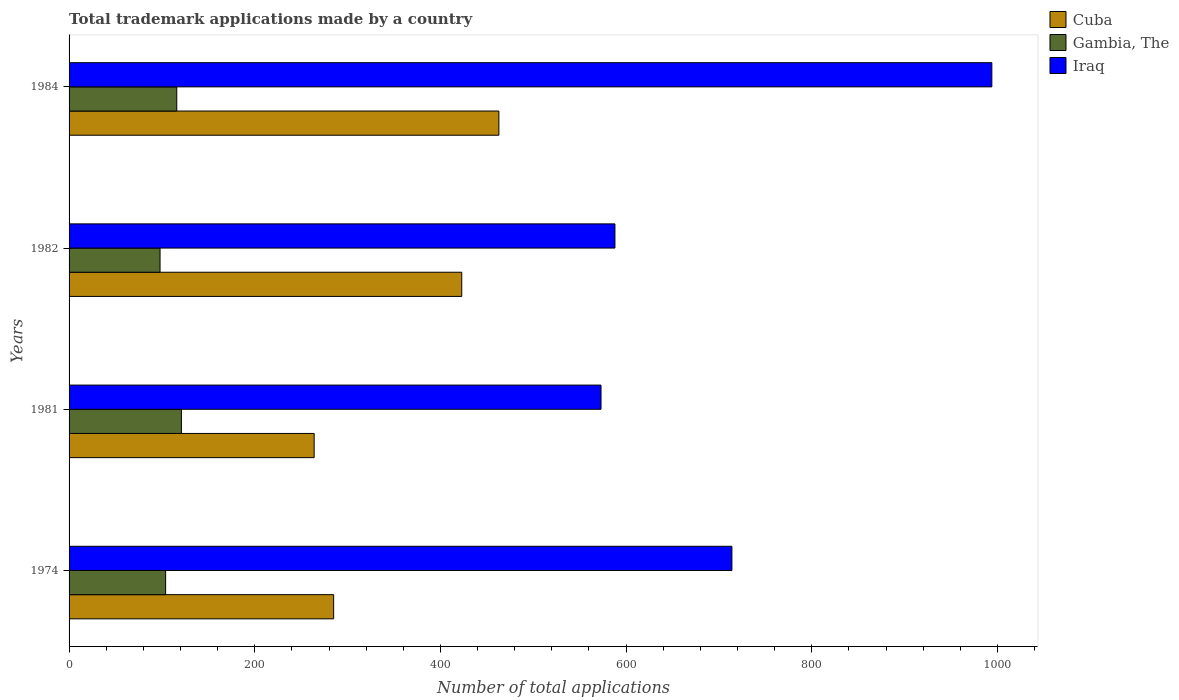How many bars are there on the 3rd tick from the bottom?
Your answer should be compact. 3. What is the label of the 1st group of bars from the top?
Offer a very short reply. 1984. What is the number of applications made by in Gambia, The in 1984?
Offer a very short reply. 116. Across all years, what is the maximum number of applications made by in Cuba?
Your answer should be compact. 463. Across all years, what is the minimum number of applications made by in Cuba?
Your response must be concise. 264. In which year was the number of applications made by in Iraq maximum?
Give a very brief answer. 1984. What is the total number of applications made by in Cuba in the graph?
Keep it short and to the point. 1435. What is the difference between the number of applications made by in Gambia, The in 1981 and that in 1984?
Offer a terse response. 5. What is the difference between the number of applications made by in Cuba in 1981 and the number of applications made by in Gambia, The in 1982?
Keep it short and to the point. 166. What is the average number of applications made by in Gambia, The per year?
Offer a very short reply. 109.75. In the year 1981, what is the difference between the number of applications made by in Gambia, The and number of applications made by in Cuba?
Keep it short and to the point. -143. In how many years, is the number of applications made by in Cuba greater than 120 ?
Ensure brevity in your answer.  4. What is the ratio of the number of applications made by in Cuba in 1982 to that in 1984?
Provide a succinct answer. 0.91. What is the difference between the highest and the lowest number of applications made by in Iraq?
Keep it short and to the point. 421. What does the 3rd bar from the top in 1982 represents?
Offer a very short reply. Cuba. What does the 2nd bar from the bottom in 1974 represents?
Provide a succinct answer. Gambia, The. Is it the case that in every year, the sum of the number of applications made by in Iraq and number of applications made by in Cuba is greater than the number of applications made by in Gambia, The?
Give a very brief answer. Yes. How many bars are there?
Your answer should be very brief. 12. Are all the bars in the graph horizontal?
Give a very brief answer. Yes. Are the values on the major ticks of X-axis written in scientific E-notation?
Your answer should be compact. No. Does the graph contain any zero values?
Give a very brief answer. No. Where does the legend appear in the graph?
Keep it short and to the point. Top right. How many legend labels are there?
Make the answer very short. 3. How are the legend labels stacked?
Provide a succinct answer. Vertical. What is the title of the graph?
Your answer should be very brief. Total trademark applications made by a country. Does "Europe(developing only)" appear as one of the legend labels in the graph?
Provide a short and direct response. No. What is the label or title of the X-axis?
Offer a terse response. Number of total applications. What is the Number of total applications in Cuba in 1974?
Your answer should be very brief. 285. What is the Number of total applications of Gambia, The in 1974?
Your response must be concise. 104. What is the Number of total applications of Iraq in 1974?
Make the answer very short. 714. What is the Number of total applications in Cuba in 1981?
Provide a short and direct response. 264. What is the Number of total applications in Gambia, The in 1981?
Offer a very short reply. 121. What is the Number of total applications in Iraq in 1981?
Offer a very short reply. 573. What is the Number of total applications of Cuba in 1982?
Make the answer very short. 423. What is the Number of total applications in Iraq in 1982?
Your answer should be compact. 588. What is the Number of total applications in Cuba in 1984?
Make the answer very short. 463. What is the Number of total applications in Gambia, The in 1984?
Offer a terse response. 116. What is the Number of total applications in Iraq in 1984?
Give a very brief answer. 994. Across all years, what is the maximum Number of total applications in Cuba?
Your answer should be compact. 463. Across all years, what is the maximum Number of total applications of Gambia, The?
Provide a succinct answer. 121. Across all years, what is the maximum Number of total applications in Iraq?
Make the answer very short. 994. Across all years, what is the minimum Number of total applications in Cuba?
Ensure brevity in your answer.  264. Across all years, what is the minimum Number of total applications in Gambia, The?
Ensure brevity in your answer.  98. Across all years, what is the minimum Number of total applications in Iraq?
Provide a short and direct response. 573. What is the total Number of total applications of Cuba in the graph?
Provide a succinct answer. 1435. What is the total Number of total applications in Gambia, The in the graph?
Your answer should be very brief. 439. What is the total Number of total applications in Iraq in the graph?
Offer a very short reply. 2869. What is the difference between the Number of total applications in Iraq in 1974 and that in 1981?
Provide a succinct answer. 141. What is the difference between the Number of total applications in Cuba in 1974 and that in 1982?
Provide a short and direct response. -138. What is the difference between the Number of total applications of Gambia, The in 1974 and that in 1982?
Provide a short and direct response. 6. What is the difference between the Number of total applications of Iraq in 1974 and that in 1982?
Make the answer very short. 126. What is the difference between the Number of total applications of Cuba in 1974 and that in 1984?
Your answer should be compact. -178. What is the difference between the Number of total applications of Iraq in 1974 and that in 1984?
Ensure brevity in your answer.  -280. What is the difference between the Number of total applications of Cuba in 1981 and that in 1982?
Offer a terse response. -159. What is the difference between the Number of total applications of Gambia, The in 1981 and that in 1982?
Your answer should be very brief. 23. What is the difference between the Number of total applications of Cuba in 1981 and that in 1984?
Provide a short and direct response. -199. What is the difference between the Number of total applications in Gambia, The in 1981 and that in 1984?
Provide a short and direct response. 5. What is the difference between the Number of total applications of Iraq in 1981 and that in 1984?
Keep it short and to the point. -421. What is the difference between the Number of total applications of Iraq in 1982 and that in 1984?
Offer a very short reply. -406. What is the difference between the Number of total applications in Cuba in 1974 and the Number of total applications in Gambia, The in 1981?
Ensure brevity in your answer.  164. What is the difference between the Number of total applications in Cuba in 1974 and the Number of total applications in Iraq in 1981?
Your answer should be compact. -288. What is the difference between the Number of total applications of Gambia, The in 1974 and the Number of total applications of Iraq in 1981?
Offer a terse response. -469. What is the difference between the Number of total applications of Cuba in 1974 and the Number of total applications of Gambia, The in 1982?
Make the answer very short. 187. What is the difference between the Number of total applications in Cuba in 1974 and the Number of total applications in Iraq in 1982?
Your answer should be very brief. -303. What is the difference between the Number of total applications in Gambia, The in 1974 and the Number of total applications in Iraq in 1982?
Keep it short and to the point. -484. What is the difference between the Number of total applications in Cuba in 1974 and the Number of total applications in Gambia, The in 1984?
Give a very brief answer. 169. What is the difference between the Number of total applications in Cuba in 1974 and the Number of total applications in Iraq in 1984?
Provide a succinct answer. -709. What is the difference between the Number of total applications in Gambia, The in 1974 and the Number of total applications in Iraq in 1984?
Provide a short and direct response. -890. What is the difference between the Number of total applications of Cuba in 1981 and the Number of total applications of Gambia, The in 1982?
Offer a terse response. 166. What is the difference between the Number of total applications in Cuba in 1981 and the Number of total applications in Iraq in 1982?
Your answer should be very brief. -324. What is the difference between the Number of total applications of Gambia, The in 1981 and the Number of total applications of Iraq in 1982?
Offer a terse response. -467. What is the difference between the Number of total applications in Cuba in 1981 and the Number of total applications in Gambia, The in 1984?
Keep it short and to the point. 148. What is the difference between the Number of total applications in Cuba in 1981 and the Number of total applications in Iraq in 1984?
Make the answer very short. -730. What is the difference between the Number of total applications in Gambia, The in 1981 and the Number of total applications in Iraq in 1984?
Ensure brevity in your answer.  -873. What is the difference between the Number of total applications in Cuba in 1982 and the Number of total applications in Gambia, The in 1984?
Provide a short and direct response. 307. What is the difference between the Number of total applications of Cuba in 1982 and the Number of total applications of Iraq in 1984?
Provide a succinct answer. -571. What is the difference between the Number of total applications in Gambia, The in 1982 and the Number of total applications in Iraq in 1984?
Make the answer very short. -896. What is the average Number of total applications of Cuba per year?
Keep it short and to the point. 358.75. What is the average Number of total applications in Gambia, The per year?
Provide a short and direct response. 109.75. What is the average Number of total applications in Iraq per year?
Make the answer very short. 717.25. In the year 1974, what is the difference between the Number of total applications of Cuba and Number of total applications of Gambia, The?
Offer a very short reply. 181. In the year 1974, what is the difference between the Number of total applications of Cuba and Number of total applications of Iraq?
Keep it short and to the point. -429. In the year 1974, what is the difference between the Number of total applications in Gambia, The and Number of total applications in Iraq?
Keep it short and to the point. -610. In the year 1981, what is the difference between the Number of total applications in Cuba and Number of total applications in Gambia, The?
Keep it short and to the point. 143. In the year 1981, what is the difference between the Number of total applications in Cuba and Number of total applications in Iraq?
Provide a succinct answer. -309. In the year 1981, what is the difference between the Number of total applications in Gambia, The and Number of total applications in Iraq?
Your answer should be compact. -452. In the year 1982, what is the difference between the Number of total applications in Cuba and Number of total applications in Gambia, The?
Keep it short and to the point. 325. In the year 1982, what is the difference between the Number of total applications of Cuba and Number of total applications of Iraq?
Give a very brief answer. -165. In the year 1982, what is the difference between the Number of total applications of Gambia, The and Number of total applications of Iraq?
Provide a succinct answer. -490. In the year 1984, what is the difference between the Number of total applications in Cuba and Number of total applications in Gambia, The?
Your answer should be very brief. 347. In the year 1984, what is the difference between the Number of total applications in Cuba and Number of total applications in Iraq?
Provide a short and direct response. -531. In the year 1984, what is the difference between the Number of total applications in Gambia, The and Number of total applications in Iraq?
Ensure brevity in your answer.  -878. What is the ratio of the Number of total applications in Cuba in 1974 to that in 1981?
Keep it short and to the point. 1.08. What is the ratio of the Number of total applications in Gambia, The in 1974 to that in 1981?
Your response must be concise. 0.86. What is the ratio of the Number of total applications of Iraq in 1974 to that in 1981?
Ensure brevity in your answer.  1.25. What is the ratio of the Number of total applications in Cuba in 1974 to that in 1982?
Ensure brevity in your answer.  0.67. What is the ratio of the Number of total applications in Gambia, The in 1974 to that in 1982?
Your answer should be compact. 1.06. What is the ratio of the Number of total applications of Iraq in 1974 to that in 1982?
Provide a short and direct response. 1.21. What is the ratio of the Number of total applications of Cuba in 1974 to that in 1984?
Ensure brevity in your answer.  0.62. What is the ratio of the Number of total applications in Gambia, The in 1974 to that in 1984?
Ensure brevity in your answer.  0.9. What is the ratio of the Number of total applications of Iraq in 1974 to that in 1984?
Make the answer very short. 0.72. What is the ratio of the Number of total applications of Cuba in 1981 to that in 1982?
Make the answer very short. 0.62. What is the ratio of the Number of total applications of Gambia, The in 1981 to that in 1982?
Your answer should be compact. 1.23. What is the ratio of the Number of total applications of Iraq in 1981 to that in 1982?
Your answer should be compact. 0.97. What is the ratio of the Number of total applications of Cuba in 1981 to that in 1984?
Provide a short and direct response. 0.57. What is the ratio of the Number of total applications in Gambia, The in 1981 to that in 1984?
Offer a very short reply. 1.04. What is the ratio of the Number of total applications of Iraq in 1981 to that in 1984?
Your answer should be very brief. 0.58. What is the ratio of the Number of total applications in Cuba in 1982 to that in 1984?
Provide a succinct answer. 0.91. What is the ratio of the Number of total applications in Gambia, The in 1982 to that in 1984?
Your response must be concise. 0.84. What is the ratio of the Number of total applications in Iraq in 1982 to that in 1984?
Provide a succinct answer. 0.59. What is the difference between the highest and the second highest Number of total applications in Gambia, The?
Your answer should be compact. 5. What is the difference between the highest and the second highest Number of total applications in Iraq?
Your answer should be very brief. 280. What is the difference between the highest and the lowest Number of total applications in Cuba?
Offer a very short reply. 199. What is the difference between the highest and the lowest Number of total applications in Gambia, The?
Your answer should be compact. 23. What is the difference between the highest and the lowest Number of total applications of Iraq?
Make the answer very short. 421. 